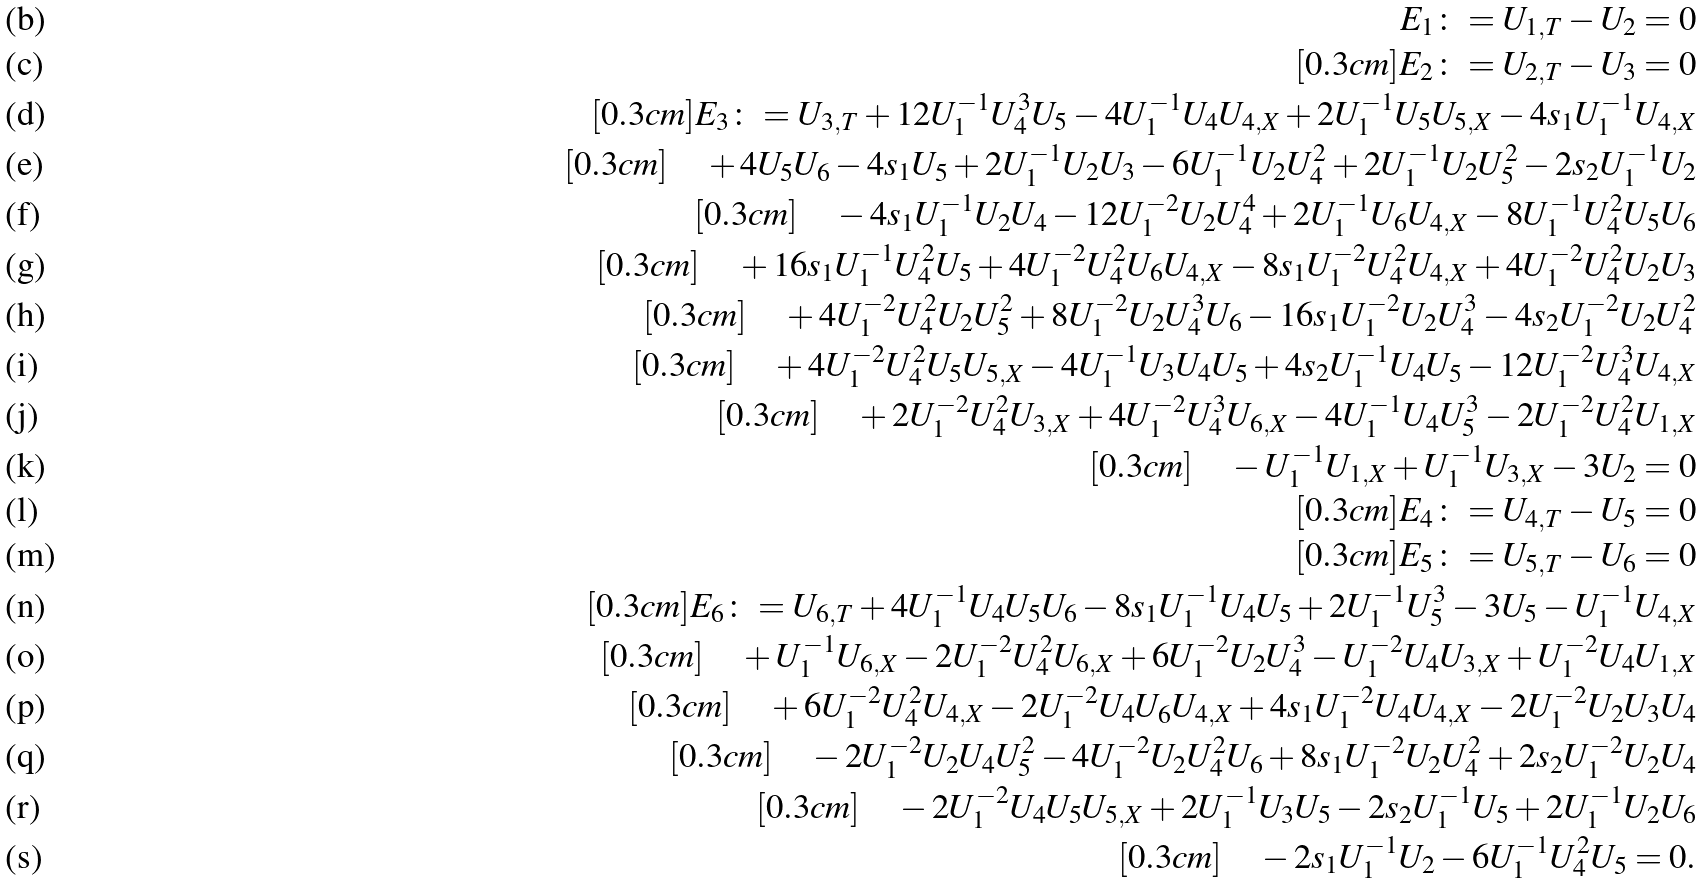Convert formula to latex. <formula><loc_0><loc_0><loc_500><loc_500>E _ { 1 } \colon = U _ { 1 , T } - U _ { 2 } = 0 \\ [ 0 . 3 c m ] E _ { 2 } \colon = U _ { 2 , T } - U _ { 3 } = 0 \\ [ 0 . 3 c m ] E _ { 3 } \colon = U _ { 3 , T } + 1 2 U _ { 1 } ^ { - 1 } U _ { 4 } ^ { 3 } U _ { 5 } - 4 U _ { 1 } ^ { - 1 } U _ { 4 } U _ { 4 , X } + 2 U _ { 1 } ^ { - 1 } U _ { 5 } U _ { 5 , X } - 4 s _ { 1 } U _ { 1 } ^ { - 1 } U _ { 4 , X } \\ [ 0 . 3 c m ] \quad + 4 U _ { 5 } U _ { 6 } - 4 s _ { 1 } U _ { 5 } + 2 U _ { 1 } ^ { - 1 } U _ { 2 } U _ { 3 } - 6 U _ { 1 } ^ { - 1 } U _ { 2 } U _ { 4 } ^ { 2 } + 2 U _ { 1 } ^ { - 1 } U _ { 2 } U _ { 5 } ^ { 2 } - 2 s _ { 2 } U _ { 1 } ^ { - 1 } U _ { 2 } \\ [ 0 . 3 c m ] \quad - 4 s _ { 1 } U _ { 1 } ^ { - 1 } U _ { 2 } U _ { 4 } - 1 2 U _ { 1 } ^ { - 2 } U _ { 2 } U _ { 4 } ^ { 4 } + 2 U _ { 1 } ^ { - 1 } U _ { 6 } U _ { 4 , X } - 8 U _ { 1 } ^ { - 1 } U _ { 4 } ^ { 2 } U _ { 5 } U _ { 6 } \\ [ 0 . 3 c m ] \quad + 1 6 s _ { 1 } U _ { 1 } ^ { - 1 } U _ { 4 } ^ { 2 } U _ { 5 } + 4 U _ { 1 } ^ { - 2 } U _ { 4 } ^ { 2 } U _ { 6 } U _ { 4 , X } - 8 s _ { 1 } U _ { 1 } ^ { - 2 } U _ { 4 } ^ { 2 } U _ { 4 , X } + 4 U _ { 1 } ^ { - 2 } U _ { 4 } ^ { 2 } U _ { 2 } U _ { 3 } \\ [ 0 . 3 c m ] \quad + 4 U _ { 1 } ^ { - 2 } U _ { 4 } ^ { 2 } U _ { 2 } U _ { 5 } ^ { 2 } + 8 U _ { 1 } ^ { - 2 } U _ { 2 } U _ { 4 } ^ { 3 } U _ { 6 } - 1 6 s _ { 1 } U _ { 1 } ^ { - 2 } U _ { 2 } U _ { 4 } ^ { 3 } - 4 s _ { 2 } U _ { 1 } ^ { - 2 } U _ { 2 } U _ { 4 } ^ { 2 } \\ [ 0 . 3 c m ] \quad + 4 U _ { 1 } ^ { - 2 } U _ { 4 } ^ { 2 } U _ { 5 } U _ { 5 , X } - 4 U _ { 1 } ^ { - 1 } U _ { 3 } U _ { 4 } U _ { 5 } + 4 s _ { 2 } U _ { 1 } ^ { - 1 } U _ { 4 } U _ { 5 } - 1 2 U _ { 1 } ^ { - 2 } U _ { 4 } ^ { 3 } U _ { 4 , X } \\ [ 0 . 3 c m ] \quad + 2 U _ { 1 } ^ { - 2 } U _ { 4 } ^ { 2 } U _ { 3 , X } + 4 U _ { 1 } ^ { - 2 } U _ { 4 } ^ { 3 } U _ { 6 , X } - 4 U _ { 1 } ^ { - 1 } U _ { 4 } U _ { 5 } ^ { 3 } - 2 U _ { 1 } ^ { - 2 } U _ { 4 } ^ { 2 } U _ { 1 , X } \\ [ 0 . 3 c m ] \quad - U _ { 1 } ^ { - 1 } U _ { 1 , X } + U _ { 1 } ^ { - 1 } U _ { 3 , X } - 3 U _ { 2 } = 0 \\ [ 0 . 3 c m ] E _ { 4 } \colon = U _ { 4 , T } - U _ { 5 } = 0 \\ [ 0 . 3 c m ] E _ { 5 } \colon = U _ { 5 , T } - U _ { 6 } = 0 \\ [ 0 . 3 c m ] E _ { 6 } \colon = U _ { 6 , T } + 4 U _ { 1 } ^ { - 1 } U _ { 4 } U _ { 5 } U _ { 6 } - 8 s _ { 1 } U _ { 1 } ^ { - 1 } U _ { 4 } U _ { 5 } + 2 U _ { 1 } ^ { - 1 } U _ { 5 } ^ { 3 } - 3 U _ { 5 } - U _ { 1 } ^ { - 1 } U _ { 4 , X } \\ [ 0 . 3 c m ] \quad + U _ { 1 } ^ { - 1 } U _ { 6 , X } - 2 U _ { 1 } ^ { - 2 } U _ { 4 } ^ { 2 } U _ { 6 , X } + 6 U _ { 1 } ^ { - 2 } U _ { 2 } U _ { 4 } ^ { 3 } - U _ { 1 } ^ { - 2 } U _ { 4 } U _ { 3 , X } + U _ { 1 } ^ { - 2 } U _ { 4 } U _ { 1 , X } \\ [ 0 . 3 c m ] \quad + 6 U _ { 1 } ^ { - 2 } U _ { 4 } ^ { 2 } U _ { 4 , X } - 2 U _ { 1 } ^ { - 2 } U _ { 4 } U _ { 6 } U _ { 4 , X } + 4 s _ { 1 } U _ { 1 } ^ { - 2 } U _ { 4 } U _ { 4 , X } - 2 U _ { 1 } ^ { - 2 } U _ { 2 } U _ { 3 } U _ { 4 } \\ [ 0 . 3 c m ] \quad - 2 U _ { 1 } ^ { - 2 } U _ { 2 } U _ { 4 } U _ { 5 } ^ { 2 } - 4 U _ { 1 } ^ { - 2 } U _ { 2 } U _ { 4 } ^ { 2 } U _ { 6 } + 8 s _ { 1 } U _ { 1 } ^ { - 2 } U _ { 2 } U _ { 4 } ^ { 2 } + 2 s _ { 2 } U _ { 1 } ^ { - 2 } U _ { 2 } U _ { 4 } \\ [ 0 . 3 c m ] \quad - 2 U _ { 1 } ^ { - 2 } U _ { 4 } U _ { 5 } U _ { 5 , X } + 2 U _ { 1 } ^ { - 1 } U _ { 3 } U _ { 5 } - 2 s _ { 2 } U _ { 1 } ^ { - 1 } U _ { 5 } + 2 U _ { 1 } ^ { - 1 } U _ { 2 } U _ { 6 } \\ [ 0 . 3 c m ] \quad - 2 s _ { 1 } U _ { 1 } ^ { - 1 } U _ { 2 } - 6 U _ { 1 } ^ { - 1 } U _ { 4 } ^ { 2 } U _ { 5 } = 0 .</formula> 